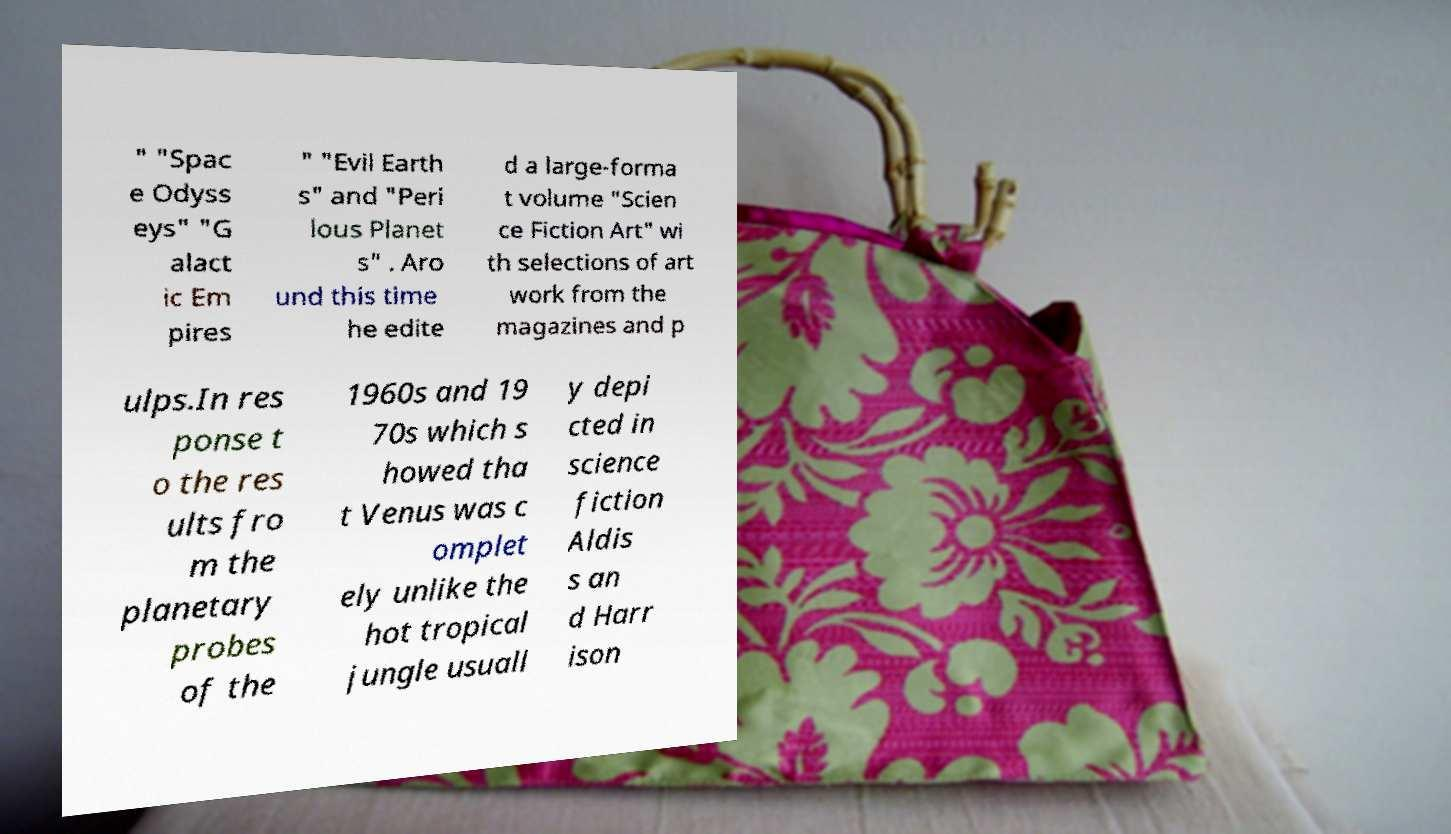Please identify and transcribe the text found in this image. " "Spac e Odyss eys" "G alact ic Em pires " "Evil Earth s" and "Peri lous Planet s" . Aro und this time he edite d a large-forma t volume "Scien ce Fiction Art" wi th selections of art work from the magazines and p ulps.In res ponse t o the res ults fro m the planetary probes of the 1960s and 19 70s which s howed tha t Venus was c omplet ely unlike the hot tropical jungle usuall y depi cted in science fiction Aldis s an d Harr ison 